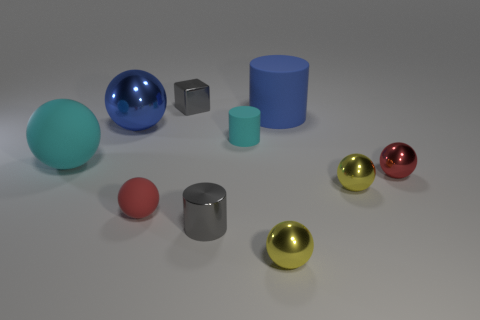Is the large shiny ball the same color as the large cylinder?
Offer a very short reply. Yes. There is a rubber ball that is behind the tiny matte ball; is it the same size as the red thing on the right side of the blue rubber cylinder?
Your answer should be very brief. No. There is a small matte object on the left side of the tiny gray shiny thing in front of the large metallic ball; what is its shape?
Your answer should be very brief. Sphere. Is the number of matte objects on the right side of the large blue cylinder the same as the number of tiny red rubber objects?
Your response must be concise. No. What is the material of the yellow sphere that is to the right of the large blue object that is behind the large blue object in front of the big blue rubber thing?
Make the answer very short. Metal. Is there a rubber object of the same size as the blue metallic ball?
Ensure brevity in your answer.  Yes. The tiny cyan rubber object has what shape?
Your answer should be very brief. Cylinder. What number of cylinders are small cyan rubber objects or cyan rubber things?
Provide a succinct answer. 1. Is the number of big matte objects that are behind the cyan rubber cylinder the same as the number of small gray things behind the red metallic thing?
Provide a succinct answer. Yes. There is a large ball that is behind the rubber thing on the left side of the large metal sphere; what number of big cylinders are behind it?
Make the answer very short. 1. 